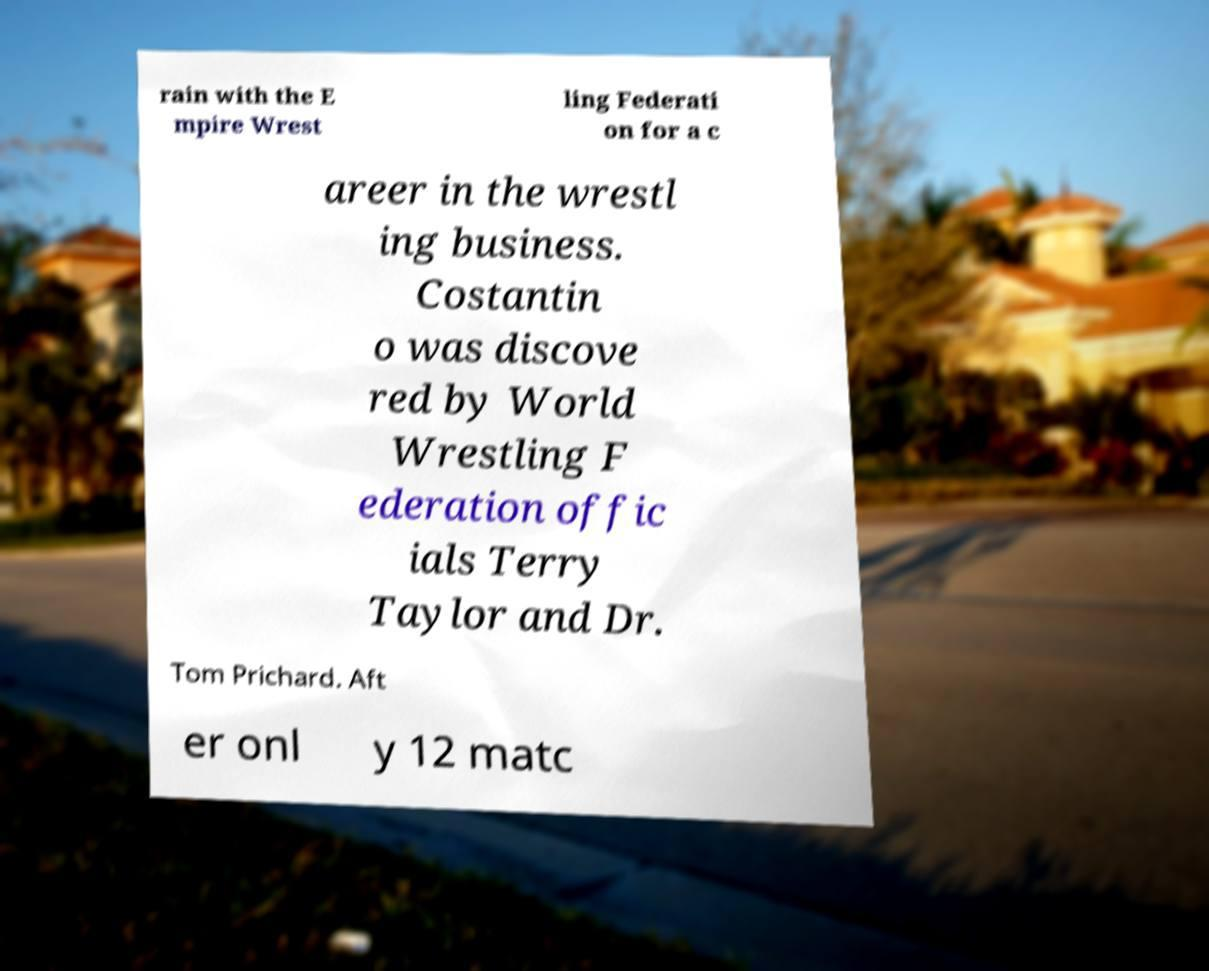Could you assist in decoding the text presented in this image and type it out clearly? rain with the E mpire Wrest ling Federati on for a c areer in the wrestl ing business. Costantin o was discove red by World Wrestling F ederation offic ials Terry Taylor and Dr. Tom Prichard. Aft er onl y 12 matc 